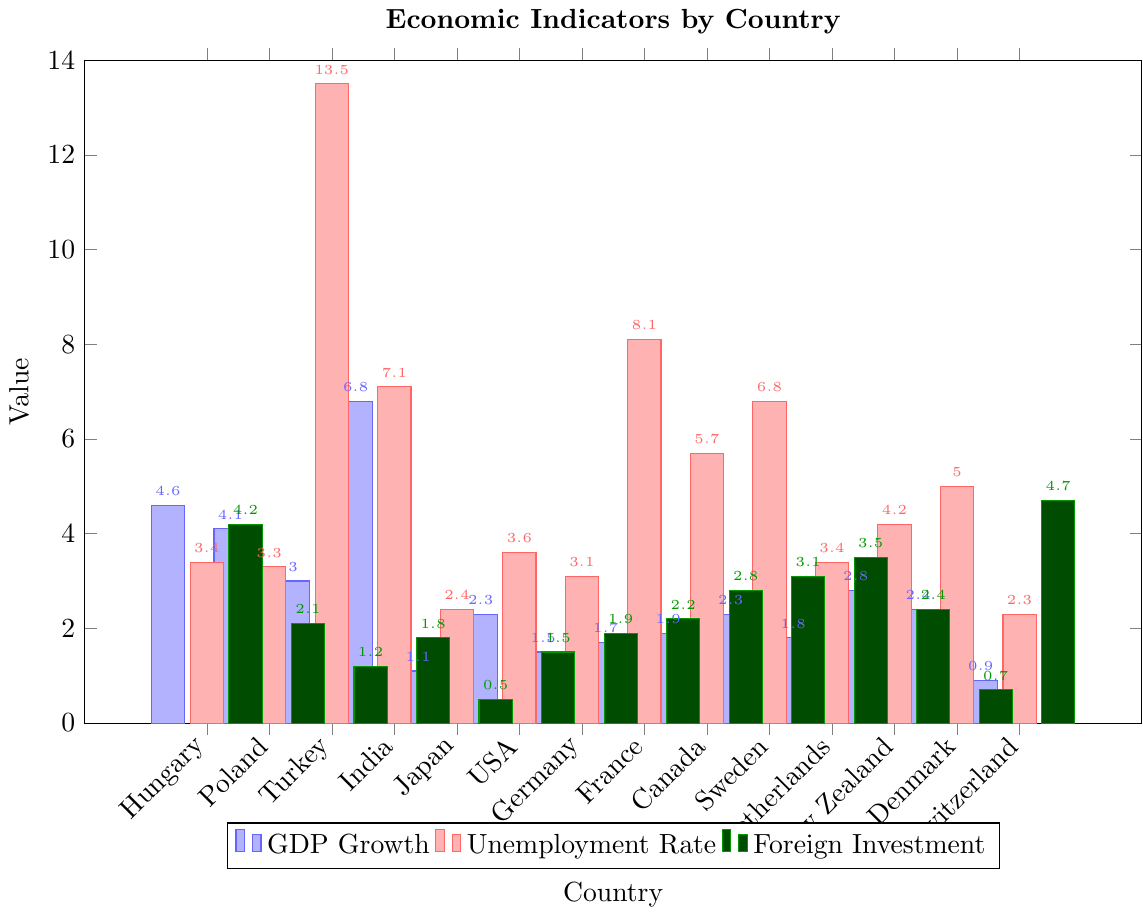Which country has the highest GDP growth rate? India has the highest GDP growth rate as indicated by the height of its blue bar, which reaches 6.8.
Answer: India Which country with a strong nationalist movement has the highest unemployment rate? Turkey has the highest unemployment rate among countries with strong nationalist movements. The red bar for Turkey reaches 13.5, which is higher than the other countries in this group.
Answer: Turkey How much greater is India's GDP growth rate compared to Japan's? India's GDP growth rate is 6.8, and Japan's is 1.1. Subtract 1.1 from 6.8 to find the difference, which is 5.7.
Answer: 5.7 What is the average foreign investment of countries with a weak nationalist movement? The foreign investment values for countries with weak nationalist movements are 2.8 (Canada), 3.1 (Sweden), 3.5 (Netherlands), 2.4 (New Zealand), 0.7 (Denmark), and 4.7 (Switzerland). Adding these gives 17.2. Dividing by 6 (the number of countries) gives an average of approximately 2.87.
Answer: 2.87 Which country has both a low unemployment rate and strong nationalist movement? Poland has a relatively low unemployment rate of 3.3 among countries with strong nationalist movements, indicated by its red bar being lower than others like Turkey and India.
Answer: Poland Which country has the smallest GDP growth rate and what is the corresponding foreign investment value? Switzerland has the smallest GDP growth rate at 0.9, and its corresponding foreign investment value, indicated by the green bar, is 4.7.
Answer: Switzerland has GDP growth of 0.9 and foreign investment of 4.7 Compare the foreign investment rates between France and Hungary. Which one is higher and by how much? France has a foreign investment rate of 2.2, while Hungary has 4.2. Subtracting 2.2 from 4.2, Hungary's rate is higher by 2.0.
Answer: Hungary by 2.0 Among countries with moderate nationalist movements, what is the total GDP growth? USA (2.3), Germany (1.5), and France (1.7). Adding these values gives a total GDP growth of 5.5.
Answer: 5.5 Which country has a moderate nationalist movement and the lowest foreign investment? The USA has a moderate nationalist movement and the lowest foreign investment, which is 1.5.
Answer: USA What is the unemployment rate of Sweden, and how does it compare to that of Japan? Sweden's unemployment rate is 6.8, while Japan's is 2.4. Subtracting 2.4 from 6.8 shows Sweden's rate is higher by 4.4 percentage points.
Answer: Sweden's rate is higher by 4.4 